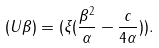<formula> <loc_0><loc_0><loc_500><loc_500>( U \beta ) = ( \xi ( \frac { \beta ^ { 2 } } { \alpha } - \frac { c } { 4 \alpha } ) ) .</formula> 